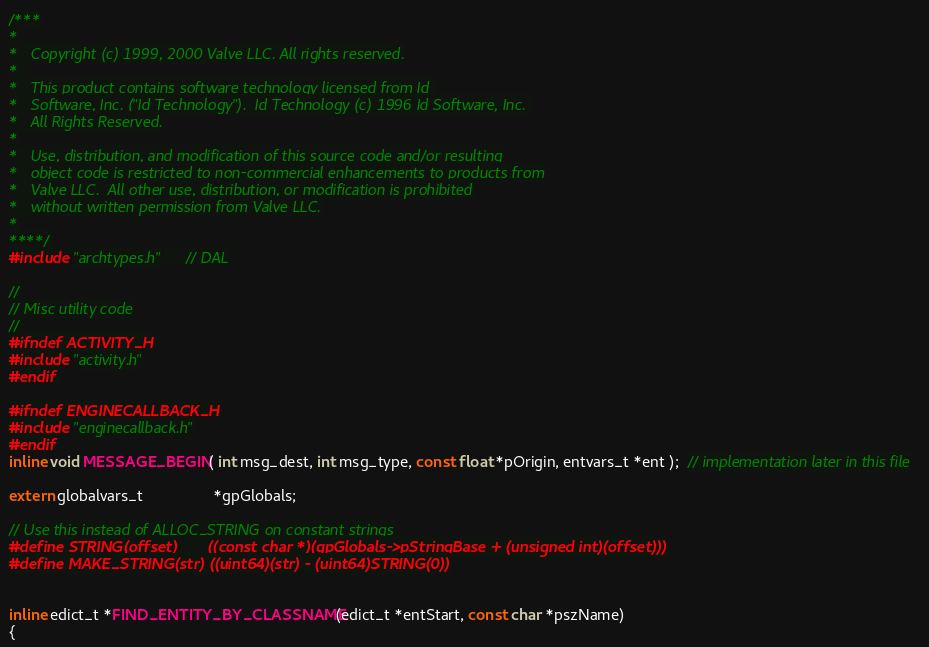<code> <loc_0><loc_0><loc_500><loc_500><_C_>/***
*
*	Copyright (c) 1999, 2000 Valve LLC. All rights reserved.
*	
*	This product contains software technology licensed from Id 
*	Software, Inc. ("Id Technology").  Id Technology (c) 1996 Id Software, Inc. 
*	All Rights Reserved.
*
*   Use, distribution, and modification of this source code and/or resulting
*   object code is restricted to non-commercial enhancements to products from
*   Valve LLC.  All other use, distribution, or modification is prohibited
*   without written permission from Valve LLC.
*
****/
#include "archtypes.h"     // DAL

//
// Misc utility code
//
#ifndef ACTIVITY_H
#include "activity.h"
#endif

#ifndef ENGINECALLBACK_H
#include "enginecallback.h"
#endif
inline void MESSAGE_BEGIN( int msg_dest, int msg_type, const float *pOrigin, entvars_t *ent );  // implementation later in this file

extern globalvars_t				*gpGlobals;

// Use this instead of ALLOC_STRING on constant strings
#define STRING(offset)		((const char *)(gpGlobals->pStringBase + (unsigned int)(offset)))
#define MAKE_STRING(str)	((uint64)(str) - (uint64)STRING(0))


inline edict_t *FIND_ENTITY_BY_CLASSNAME(edict_t *entStart, const char *pszName) 
{</code> 